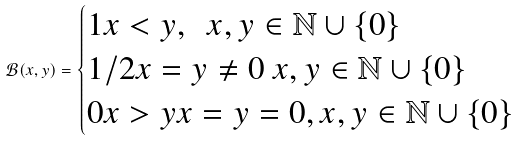Convert formula to latex. <formula><loc_0><loc_0><loc_500><loc_500>\mathcal { B } ( x , y ) = { \begin{cases} 1 x < y , \ \ x , y \in \mathbb { N } \cup \{ 0 \} \\ 1 / 2 x = y \ne 0 \ x , y \in \mathbb { N } \cup \{ 0 \} \\ 0 x > y x = y = 0 , x , y \in \mathbb { N } \cup \{ 0 \} \end{cases} }</formula> 